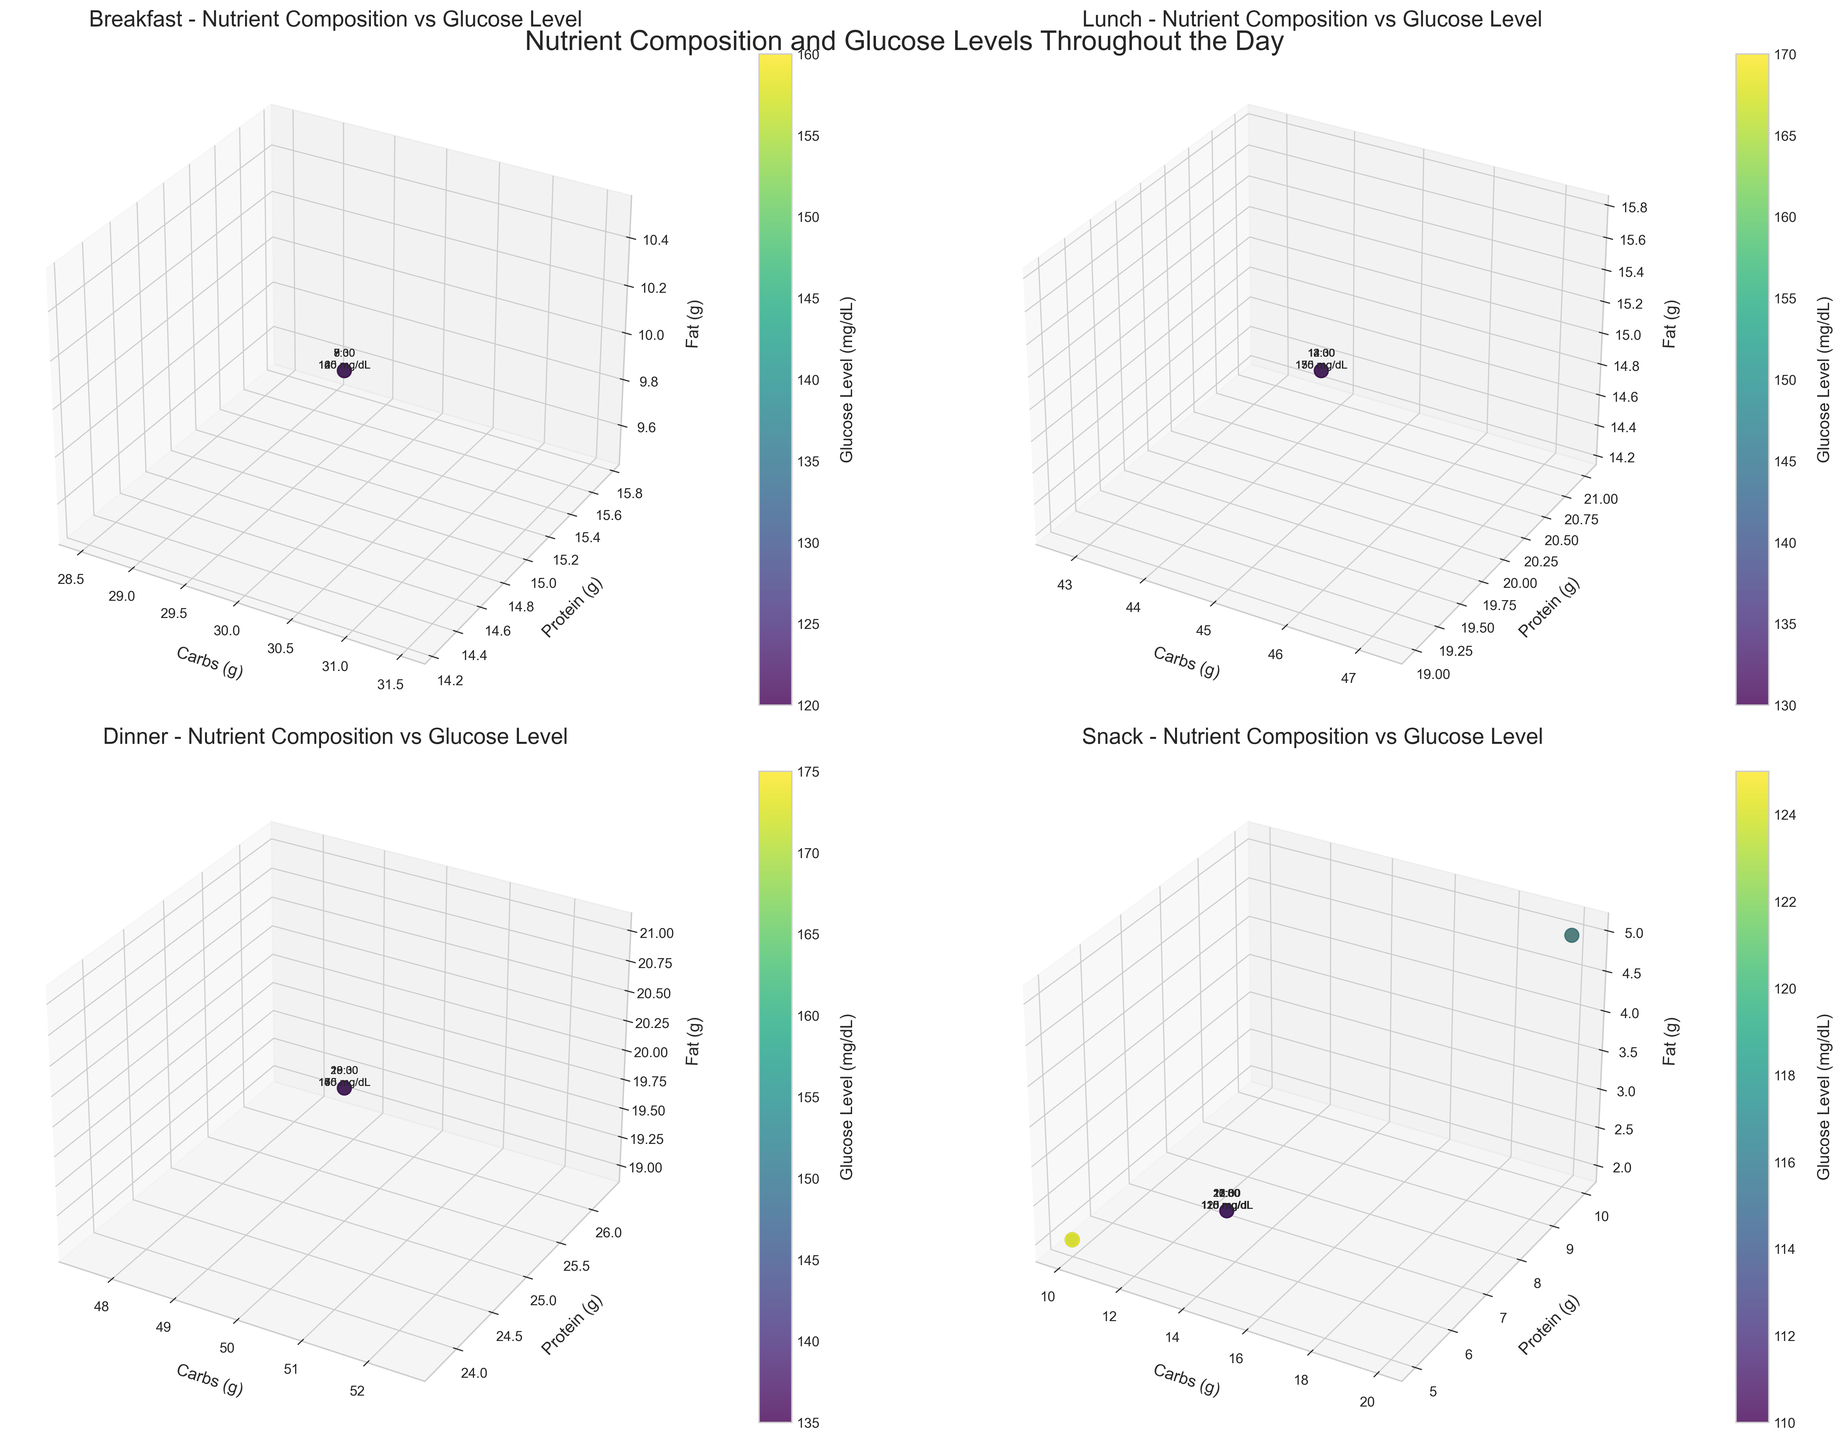What's the title of the figure? The title of the figure is displayed at the top of the overall figure. It is usually set to describe the content and purpose of the visual.
Answer: "Nutrient Composition and Glucose Levels Throughout the Day" How many subplot sections are there in the figure? The figure is divided into individual subplot sections, each representing data for a specific meal type. By counting these sections, we can determine the total number of meal-type subsections.
Answer: 4 Which meal type shows the highest glucose level? By examining the scatter plots in each subplot and locating the highest point on the color bar (glucose level), we can see which meal type has the highest glucose level. The Dinner subplot shows the highest mark, reaching over 170 mg/dL.
Answer: Dinner What’s the carb count and corresponding time for the lowest glucose level in the Lunch meal? By checking the subplot for Lunch and finding the point with the lowest position on the color bar, we can identify all linked details, including the carb count and the exact time. The point with glucose level 130 mg/dL corresponds to a carb count of 45 grams and a time of 12:30.
Answer: 45 grams, 12:30 Which meal type maintains the most stable glucose levels the longest? We analyze the spread of glucose levels (color consistency) in each scatter plot. Snack meals, which show less fluctuation in color intensity, indicate that they maintain a stable glucose level better than others.
Answer: Snack What’s the average protein intake for Dinner meals? Calculate the average protein grams by adding up all protein values for Dinner meals and dividing by the number of entries. Dinner has 5 measurements with a consistent protein content of 25 grams, thus, the total (25*5) divided by 5 results in an average protein intake.
Answer: 25 grams Which meal type has the highest variability in glucose levels? By examining the color gradient variation in each subplot, one can see how spread-out the glucose levels are. Dinner stands out with a broad range of glucose levels from 135 mg/dL to 175 mg/dL, indicating the highest variability.
Answer: Dinner What month does the data span from? By looking at the time patterns in the data presented in each subplot, we can infer that this set of measurements was taken on a single day rather than across a month, given the specific meal times and measurements before bed.
Answer: One day How do carb intake and glucose levels correlate at Breakfast? To understand this, one must look at the Breakfast subplot. Track carb grams on the x-axis against changes in glucose levels (color). As carb intake remains constant, the initial increase in glucose levels shows a correlation before it eventually drops back down to the baseline levels.
Answer: Initial correlation, then stabilizes 